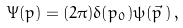Convert formula to latex. <formula><loc_0><loc_0><loc_500><loc_500>\Psi ( p ) = ( 2 \pi ) \delta ( p _ { 0 } ) \psi ( \vec { p } \, ) \, ,</formula> 